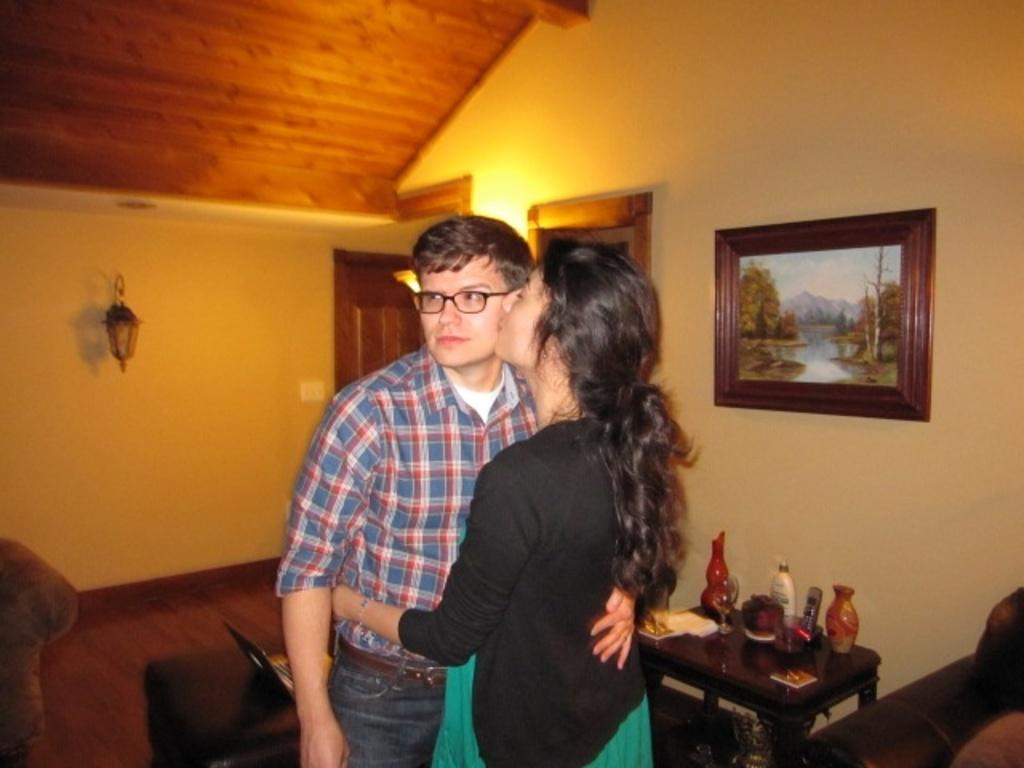How many people are in the image? There are two people in the image. Can you describe the gender of the people in the image? One of the people is a woman, and the other person is a man. What is the woman doing to the man in the image? The woman is kissing the man on his cheek. What type of soup is the woman requesting from the man in the image? There is no soup or request present in the image; the woman is kissing the man on his cheek. 